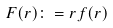<formula> <loc_0><loc_0><loc_500><loc_500>F ( r ) \colon = r f ( r )</formula> 